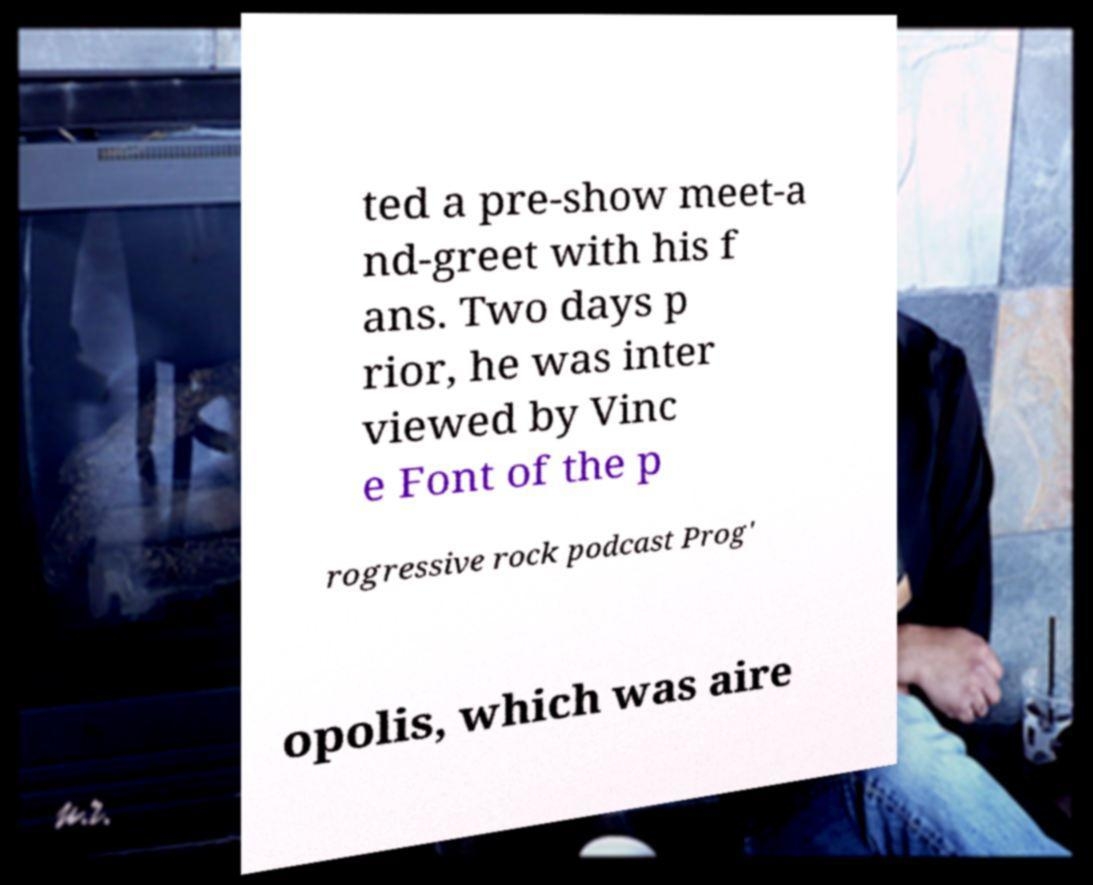What messages or text are displayed in this image? I need them in a readable, typed format. ted a pre-show meet-a nd-greet with his f ans. Two days p rior, he was inter viewed by Vinc e Font of the p rogressive rock podcast Prog' opolis, which was aire 